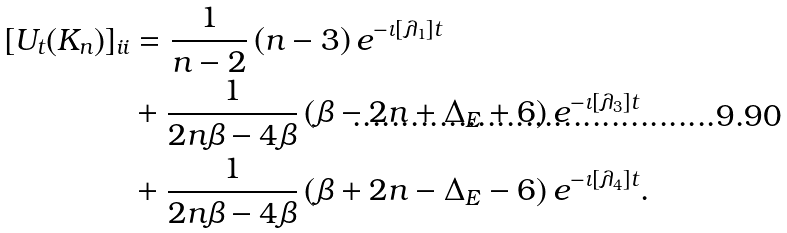<formula> <loc_0><loc_0><loc_500><loc_500>[ U _ { t } ( K _ { n } ) ] _ { i i } & = \frac { 1 } { n - 2 } \left ( n - 3 \right ) e ^ { - \iota \left [ \lambda _ { 1 } \right ] t } \\ & + \frac { 1 } { 2 n \beta - 4 \beta } \left ( \beta - 2 n + \Delta _ { E } + 6 \right ) e ^ { - \iota \left [ \lambda _ { 3 } \right ] t } \\ & + \frac { 1 } { 2 n \beta - 4 \beta } \left ( \beta + 2 n - \Delta _ { E } - 6 \right ) e ^ { - \iota \left [ \lambda _ { 4 } \right ] t } .</formula> 